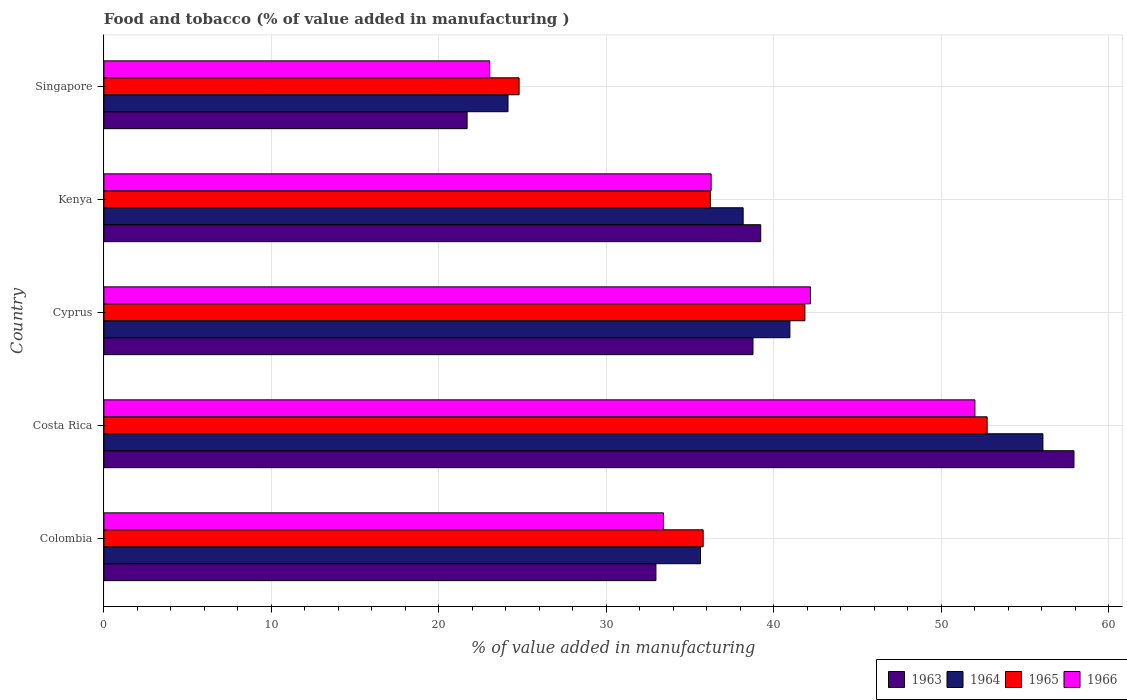How many different coloured bars are there?
Your answer should be very brief. 4. How many groups of bars are there?
Keep it short and to the point. 5. How many bars are there on the 1st tick from the top?
Give a very brief answer. 4. What is the label of the 3rd group of bars from the top?
Your answer should be compact. Cyprus. What is the value added in manufacturing food and tobacco in 1964 in Cyprus?
Give a very brief answer. 40.96. Across all countries, what is the maximum value added in manufacturing food and tobacco in 1965?
Provide a short and direct response. 52.73. Across all countries, what is the minimum value added in manufacturing food and tobacco in 1966?
Your response must be concise. 23.04. In which country was the value added in manufacturing food and tobacco in 1964 maximum?
Give a very brief answer. Costa Rica. In which country was the value added in manufacturing food and tobacco in 1964 minimum?
Your response must be concise. Singapore. What is the total value added in manufacturing food and tobacco in 1964 in the graph?
Give a very brief answer. 194.94. What is the difference between the value added in manufacturing food and tobacco in 1963 in Cyprus and that in Kenya?
Make the answer very short. -0.46. What is the difference between the value added in manufacturing food and tobacco in 1966 in Colombia and the value added in manufacturing food and tobacco in 1963 in Singapore?
Provide a succinct answer. 11.72. What is the average value added in manufacturing food and tobacco in 1966 per country?
Your answer should be compact. 37.38. What is the difference between the value added in manufacturing food and tobacco in 1966 and value added in manufacturing food and tobacco in 1964 in Colombia?
Offer a very short reply. -2.21. In how many countries, is the value added in manufacturing food and tobacco in 1964 greater than 46 %?
Your response must be concise. 1. What is the ratio of the value added in manufacturing food and tobacco in 1965 in Costa Rica to that in Cyprus?
Your response must be concise. 1.26. Is the value added in manufacturing food and tobacco in 1963 in Colombia less than that in Costa Rica?
Keep it short and to the point. Yes. Is the difference between the value added in manufacturing food and tobacco in 1966 in Costa Rica and Kenya greater than the difference between the value added in manufacturing food and tobacco in 1964 in Costa Rica and Kenya?
Offer a very short reply. No. What is the difference between the highest and the second highest value added in manufacturing food and tobacco in 1964?
Offer a terse response. 15.11. What is the difference between the highest and the lowest value added in manufacturing food and tobacco in 1965?
Your answer should be compact. 27.94. In how many countries, is the value added in manufacturing food and tobacco in 1963 greater than the average value added in manufacturing food and tobacco in 1963 taken over all countries?
Provide a succinct answer. 3. What does the 2nd bar from the bottom in Kenya represents?
Keep it short and to the point. 1964. Is it the case that in every country, the sum of the value added in manufacturing food and tobacco in 1965 and value added in manufacturing food and tobacco in 1963 is greater than the value added in manufacturing food and tobacco in 1964?
Offer a terse response. Yes. How many bars are there?
Make the answer very short. 20. How many countries are there in the graph?
Your response must be concise. 5. What is the difference between two consecutive major ticks on the X-axis?
Your answer should be compact. 10. Are the values on the major ticks of X-axis written in scientific E-notation?
Your answer should be compact. No. Does the graph contain any zero values?
Offer a terse response. No. Does the graph contain grids?
Keep it short and to the point. Yes. What is the title of the graph?
Keep it short and to the point. Food and tobacco (% of value added in manufacturing ). Does "2011" appear as one of the legend labels in the graph?
Your answer should be very brief. No. What is the label or title of the X-axis?
Your response must be concise. % of value added in manufacturing. What is the label or title of the Y-axis?
Give a very brief answer. Country. What is the % of value added in manufacturing in 1963 in Colombia?
Make the answer very short. 32.96. What is the % of value added in manufacturing in 1964 in Colombia?
Give a very brief answer. 35.62. What is the % of value added in manufacturing of 1965 in Colombia?
Ensure brevity in your answer.  35.78. What is the % of value added in manufacturing in 1966 in Colombia?
Offer a terse response. 33.41. What is the % of value added in manufacturing of 1963 in Costa Rica?
Ensure brevity in your answer.  57.92. What is the % of value added in manufacturing in 1964 in Costa Rica?
Your response must be concise. 56.07. What is the % of value added in manufacturing in 1965 in Costa Rica?
Make the answer very short. 52.73. What is the % of value added in manufacturing in 1966 in Costa Rica?
Offer a terse response. 52. What is the % of value added in manufacturing of 1963 in Cyprus?
Ensure brevity in your answer.  38.75. What is the % of value added in manufacturing in 1964 in Cyprus?
Offer a terse response. 40.96. What is the % of value added in manufacturing of 1965 in Cyprus?
Keep it short and to the point. 41.85. What is the % of value added in manufacturing in 1966 in Cyprus?
Offer a terse response. 42.19. What is the % of value added in manufacturing of 1963 in Kenya?
Provide a succinct answer. 39.22. What is the % of value added in manufacturing in 1964 in Kenya?
Your answer should be very brief. 38.17. What is the % of value added in manufacturing of 1965 in Kenya?
Provide a succinct answer. 36.2. What is the % of value added in manufacturing in 1966 in Kenya?
Your answer should be compact. 36.25. What is the % of value added in manufacturing of 1963 in Singapore?
Offer a terse response. 21.69. What is the % of value added in manufacturing of 1964 in Singapore?
Offer a very short reply. 24.13. What is the % of value added in manufacturing in 1965 in Singapore?
Your answer should be very brief. 24.79. What is the % of value added in manufacturing of 1966 in Singapore?
Provide a short and direct response. 23.04. Across all countries, what is the maximum % of value added in manufacturing of 1963?
Keep it short and to the point. 57.92. Across all countries, what is the maximum % of value added in manufacturing of 1964?
Give a very brief answer. 56.07. Across all countries, what is the maximum % of value added in manufacturing in 1965?
Offer a very short reply. 52.73. Across all countries, what is the maximum % of value added in manufacturing in 1966?
Ensure brevity in your answer.  52. Across all countries, what is the minimum % of value added in manufacturing in 1963?
Offer a very short reply. 21.69. Across all countries, what is the minimum % of value added in manufacturing in 1964?
Keep it short and to the point. 24.13. Across all countries, what is the minimum % of value added in manufacturing of 1965?
Offer a terse response. 24.79. Across all countries, what is the minimum % of value added in manufacturing in 1966?
Your answer should be compact. 23.04. What is the total % of value added in manufacturing of 1963 in the graph?
Offer a terse response. 190.54. What is the total % of value added in manufacturing of 1964 in the graph?
Give a very brief answer. 194.94. What is the total % of value added in manufacturing in 1965 in the graph?
Your answer should be very brief. 191.36. What is the total % of value added in manufacturing in 1966 in the graph?
Ensure brevity in your answer.  186.89. What is the difference between the % of value added in manufacturing in 1963 in Colombia and that in Costa Rica?
Your answer should be very brief. -24.96. What is the difference between the % of value added in manufacturing of 1964 in Colombia and that in Costa Rica?
Ensure brevity in your answer.  -20.45. What is the difference between the % of value added in manufacturing of 1965 in Colombia and that in Costa Rica?
Your answer should be compact. -16.95. What is the difference between the % of value added in manufacturing in 1966 in Colombia and that in Costa Rica?
Your response must be concise. -18.59. What is the difference between the % of value added in manufacturing in 1963 in Colombia and that in Cyprus?
Offer a terse response. -5.79. What is the difference between the % of value added in manufacturing in 1964 in Colombia and that in Cyprus?
Give a very brief answer. -5.34. What is the difference between the % of value added in manufacturing in 1965 in Colombia and that in Cyprus?
Ensure brevity in your answer.  -6.07. What is the difference between the % of value added in manufacturing of 1966 in Colombia and that in Cyprus?
Offer a terse response. -8.78. What is the difference between the % of value added in manufacturing of 1963 in Colombia and that in Kenya?
Give a very brief answer. -6.26. What is the difference between the % of value added in manufacturing in 1964 in Colombia and that in Kenya?
Offer a terse response. -2.55. What is the difference between the % of value added in manufacturing in 1965 in Colombia and that in Kenya?
Your response must be concise. -0.42. What is the difference between the % of value added in manufacturing in 1966 in Colombia and that in Kenya?
Your answer should be very brief. -2.84. What is the difference between the % of value added in manufacturing in 1963 in Colombia and that in Singapore?
Make the answer very short. 11.27. What is the difference between the % of value added in manufacturing of 1964 in Colombia and that in Singapore?
Your response must be concise. 11.49. What is the difference between the % of value added in manufacturing in 1965 in Colombia and that in Singapore?
Your answer should be compact. 10.99. What is the difference between the % of value added in manufacturing of 1966 in Colombia and that in Singapore?
Your answer should be compact. 10.37. What is the difference between the % of value added in manufacturing of 1963 in Costa Rica and that in Cyprus?
Provide a short and direct response. 19.17. What is the difference between the % of value added in manufacturing in 1964 in Costa Rica and that in Cyprus?
Offer a very short reply. 15.11. What is the difference between the % of value added in manufacturing of 1965 in Costa Rica and that in Cyprus?
Offer a terse response. 10.88. What is the difference between the % of value added in manufacturing of 1966 in Costa Rica and that in Cyprus?
Give a very brief answer. 9.82. What is the difference between the % of value added in manufacturing in 1963 in Costa Rica and that in Kenya?
Give a very brief answer. 18.7. What is the difference between the % of value added in manufacturing in 1964 in Costa Rica and that in Kenya?
Give a very brief answer. 17.9. What is the difference between the % of value added in manufacturing of 1965 in Costa Rica and that in Kenya?
Offer a very short reply. 16.53. What is the difference between the % of value added in manufacturing in 1966 in Costa Rica and that in Kenya?
Your answer should be very brief. 15.75. What is the difference between the % of value added in manufacturing of 1963 in Costa Rica and that in Singapore?
Your answer should be compact. 36.23. What is the difference between the % of value added in manufacturing of 1964 in Costa Rica and that in Singapore?
Ensure brevity in your answer.  31.94. What is the difference between the % of value added in manufacturing in 1965 in Costa Rica and that in Singapore?
Provide a succinct answer. 27.94. What is the difference between the % of value added in manufacturing in 1966 in Costa Rica and that in Singapore?
Your answer should be compact. 28.97. What is the difference between the % of value added in manufacturing of 1963 in Cyprus and that in Kenya?
Make the answer very short. -0.46. What is the difference between the % of value added in manufacturing in 1964 in Cyprus and that in Kenya?
Your answer should be compact. 2.79. What is the difference between the % of value added in manufacturing of 1965 in Cyprus and that in Kenya?
Keep it short and to the point. 5.65. What is the difference between the % of value added in manufacturing of 1966 in Cyprus and that in Kenya?
Your answer should be very brief. 5.93. What is the difference between the % of value added in manufacturing of 1963 in Cyprus and that in Singapore?
Make the answer very short. 17.07. What is the difference between the % of value added in manufacturing in 1964 in Cyprus and that in Singapore?
Your answer should be very brief. 16.83. What is the difference between the % of value added in manufacturing of 1965 in Cyprus and that in Singapore?
Offer a very short reply. 17.06. What is the difference between the % of value added in manufacturing of 1966 in Cyprus and that in Singapore?
Provide a short and direct response. 19.15. What is the difference between the % of value added in manufacturing in 1963 in Kenya and that in Singapore?
Offer a very short reply. 17.53. What is the difference between the % of value added in manufacturing of 1964 in Kenya and that in Singapore?
Give a very brief answer. 14.04. What is the difference between the % of value added in manufacturing of 1965 in Kenya and that in Singapore?
Make the answer very short. 11.41. What is the difference between the % of value added in manufacturing of 1966 in Kenya and that in Singapore?
Offer a very short reply. 13.22. What is the difference between the % of value added in manufacturing in 1963 in Colombia and the % of value added in manufacturing in 1964 in Costa Rica?
Ensure brevity in your answer.  -23.11. What is the difference between the % of value added in manufacturing of 1963 in Colombia and the % of value added in manufacturing of 1965 in Costa Rica?
Ensure brevity in your answer.  -19.77. What is the difference between the % of value added in manufacturing of 1963 in Colombia and the % of value added in manufacturing of 1966 in Costa Rica?
Your answer should be very brief. -19.04. What is the difference between the % of value added in manufacturing in 1964 in Colombia and the % of value added in manufacturing in 1965 in Costa Rica?
Your response must be concise. -17.11. What is the difference between the % of value added in manufacturing of 1964 in Colombia and the % of value added in manufacturing of 1966 in Costa Rica?
Give a very brief answer. -16.38. What is the difference between the % of value added in manufacturing of 1965 in Colombia and the % of value added in manufacturing of 1966 in Costa Rica?
Your response must be concise. -16.22. What is the difference between the % of value added in manufacturing in 1963 in Colombia and the % of value added in manufacturing in 1964 in Cyprus?
Keep it short and to the point. -8. What is the difference between the % of value added in manufacturing of 1963 in Colombia and the % of value added in manufacturing of 1965 in Cyprus?
Offer a terse response. -8.89. What is the difference between the % of value added in manufacturing of 1963 in Colombia and the % of value added in manufacturing of 1966 in Cyprus?
Make the answer very short. -9.23. What is the difference between the % of value added in manufacturing in 1964 in Colombia and the % of value added in manufacturing in 1965 in Cyprus?
Make the answer very short. -6.23. What is the difference between the % of value added in manufacturing of 1964 in Colombia and the % of value added in manufacturing of 1966 in Cyprus?
Your answer should be compact. -6.57. What is the difference between the % of value added in manufacturing in 1965 in Colombia and the % of value added in manufacturing in 1966 in Cyprus?
Give a very brief answer. -6.41. What is the difference between the % of value added in manufacturing of 1963 in Colombia and the % of value added in manufacturing of 1964 in Kenya?
Give a very brief answer. -5.21. What is the difference between the % of value added in manufacturing in 1963 in Colombia and the % of value added in manufacturing in 1965 in Kenya?
Offer a terse response. -3.24. What is the difference between the % of value added in manufacturing in 1963 in Colombia and the % of value added in manufacturing in 1966 in Kenya?
Your answer should be very brief. -3.29. What is the difference between the % of value added in manufacturing in 1964 in Colombia and the % of value added in manufacturing in 1965 in Kenya?
Your answer should be compact. -0.58. What is the difference between the % of value added in manufacturing in 1964 in Colombia and the % of value added in manufacturing in 1966 in Kenya?
Provide a succinct answer. -0.63. What is the difference between the % of value added in manufacturing in 1965 in Colombia and the % of value added in manufacturing in 1966 in Kenya?
Ensure brevity in your answer.  -0.47. What is the difference between the % of value added in manufacturing of 1963 in Colombia and the % of value added in manufacturing of 1964 in Singapore?
Make the answer very short. 8.83. What is the difference between the % of value added in manufacturing of 1963 in Colombia and the % of value added in manufacturing of 1965 in Singapore?
Keep it short and to the point. 8.17. What is the difference between the % of value added in manufacturing in 1963 in Colombia and the % of value added in manufacturing in 1966 in Singapore?
Make the answer very short. 9.92. What is the difference between the % of value added in manufacturing of 1964 in Colombia and the % of value added in manufacturing of 1965 in Singapore?
Offer a very short reply. 10.83. What is the difference between the % of value added in manufacturing in 1964 in Colombia and the % of value added in manufacturing in 1966 in Singapore?
Keep it short and to the point. 12.58. What is the difference between the % of value added in manufacturing in 1965 in Colombia and the % of value added in manufacturing in 1966 in Singapore?
Keep it short and to the point. 12.74. What is the difference between the % of value added in manufacturing of 1963 in Costa Rica and the % of value added in manufacturing of 1964 in Cyprus?
Your answer should be compact. 16.96. What is the difference between the % of value added in manufacturing in 1963 in Costa Rica and the % of value added in manufacturing in 1965 in Cyprus?
Your response must be concise. 16.07. What is the difference between the % of value added in manufacturing of 1963 in Costa Rica and the % of value added in manufacturing of 1966 in Cyprus?
Offer a terse response. 15.73. What is the difference between the % of value added in manufacturing of 1964 in Costa Rica and the % of value added in manufacturing of 1965 in Cyprus?
Offer a very short reply. 14.21. What is the difference between the % of value added in manufacturing in 1964 in Costa Rica and the % of value added in manufacturing in 1966 in Cyprus?
Your answer should be compact. 13.88. What is the difference between the % of value added in manufacturing in 1965 in Costa Rica and the % of value added in manufacturing in 1966 in Cyprus?
Your response must be concise. 10.55. What is the difference between the % of value added in manufacturing in 1963 in Costa Rica and the % of value added in manufacturing in 1964 in Kenya?
Offer a terse response. 19.75. What is the difference between the % of value added in manufacturing of 1963 in Costa Rica and the % of value added in manufacturing of 1965 in Kenya?
Provide a short and direct response. 21.72. What is the difference between the % of value added in manufacturing in 1963 in Costa Rica and the % of value added in manufacturing in 1966 in Kenya?
Give a very brief answer. 21.67. What is the difference between the % of value added in manufacturing in 1964 in Costa Rica and the % of value added in manufacturing in 1965 in Kenya?
Provide a succinct answer. 19.86. What is the difference between the % of value added in manufacturing in 1964 in Costa Rica and the % of value added in manufacturing in 1966 in Kenya?
Give a very brief answer. 19.81. What is the difference between the % of value added in manufacturing of 1965 in Costa Rica and the % of value added in manufacturing of 1966 in Kenya?
Ensure brevity in your answer.  16.48. What is the difference between the % of value added in manufacturing in 1963 in Costa Rica and the % of value added in manufacturing in 1964 in Singapore?
Ensure brevity in your answer.  33.79. What is the difference between the % of value added in manufacturing of 1963 in Costa Rica and the % of value added in manufacturing of 1965 in Singapore?
Give a very brief answer. 33.13. What is the difference between the % of value added in manufacturing in 1963 in Costa Rica and the % of value added in manufacturing in 1966 in Singapore?
Give a very brief answer. 34.88. What is the difference between the % of value added in manufacturing of 1964 in Costa Rica and the % of value added in manufacturing of 1965 in Singapore?
Keep it short and to the point. 31.28. What is the difference between the % of value added in manufacturing of 1964 in Costa Rica and the % of value added in manufacturing of 1966 in Singapore?
Offer a very short reply. 33.03. What is the difference between the % of value added in manufacturing in 1965 in Costa Rica and the % of value added in manufacturing in 1966 in Singapore?
Give a very brief answer. 29.7. What is the difference between the % of value added in manufacturing in 1963 in Cyprus and the % of value added in manufacturing in 1964 in Kenya?
Your answer should be compact. 0.59. What is the difference between the % of value added in manufacturing in 1963 in Cyprus and the % of value added in manufacturing in 1965 in Kenya?
Keep it short and to the point. 2.55. What is the difference between the % of value added in manufacturing in 1963 in Cyprus and the % of value added in manufacturing in 1966 in Kenya?
Your response must be concise. 2.5. What is the difference between the % of value added in manufacturing of 1964 in Cyprus and the % of value added in manufacturing of 1965 in Kenya?
Give a very brief answer. 4.75. What is the difference between the % of value added in manufacturing in 1964 in Cyprus and the % of value added in manufacturing in 1966 in Kenya?
Your response must be concise. 4.7. What is the difference between the % of value added in manufacturing of 1965 in Cyprus and the % of value added in manufacturing of 1966 in Kenya?
Your answer should be compact. 5.6. What is the difference between the % of value added in manufacturing of 1963 in Cyprus and the % of value added in manufacturing of 1964 in Singapore?
Provide a succinct answer. 14.63. What is the difference between the % of value added in manufacturing of 1963 in Cyprus and the % of value added in manufacturing of 1965 in Singapore?
Make the answer very short. 13.96. What is the difference between the % of value added in manufacturing of 1963 in Cyprus and the % of value added in manufacturing of 1966 in Singapore?
Your response must be concise. 15.72. What is the difference between the % of value added in manufacturing in 1964 in Cyprus and the % of value added in manufacturing in 1965 in Singapore?
Your answer should be very brief. 16.17. What is the difference between the % of value added in manufacturing of 1964 in Cyprus and the % of value added in manufacturing of 1966 in Singapore?
Your response must be concise. 17.92. What is the difference between the % of value added in manufacturing of 1965 in Cyprus and the % of value added in manufacturing of 1966 in Singapore?
Provide a succinct answer. 18.82. What is the difference between the % of value added in manufacturing in 1963 in Kenya and the % of value added in manufacturing in 1964 in Singapore?
Your answer should be compact. 15.09. What is the difference between the % of value added in manufacturing in 1963 in Kenya and the % of value added in manufacturing in 1965 in Singapore?
Keep it short and to the point. 14.43. What is the difference between the % of value added in manufacturing in 1963 in Kenya and the % of value added in manufacturing in 1966 in Singapore?
Keep it short and to the point. 16.18. What is the difference between the % of value added in manufacturing of 1964 in Kenya and the % of value added in manufacturing of 1965 in Singapore?
Make the answer very short. 13.38. What is the difference between the % of value added in manufacturing of 1964 in Kenya and the % of value added in manufacturing of 1966 in Singapore?
Your answer should be compact. 15.13. What is the difference between the % of value added in manufacturing of 1965 in Kenya and the % of value added in manufacturing of 1966 in Singapore?
Keep it short and to the point. 13.17. What is the average % of value added in manufacturing of 1963 per country?
Provide a succinct answer. 38.11. What is the average % of value added in manufacturing in 1964 per country?
Offer a terse response. 38.99. What is the average % of value added in manufacturing in 1965 per country?
Provide a succinct answer. 38.27. What is the average % of value added in manufacturing in 1966 per country?
Ensure brevity in your answer.  37.38. What is the difference between the % of value added in manufacturing of 1963 and % of value added in manufacturing of 1964 in Colombia?
Make the answer very short. -2.66. What is the difference between the % of value added in manufacturing in 1963 and % of value added in manufacturing in 1965 in Colombia?
Your answer should be very brief. -2.82. What is the difference between the % of value added in manufacturing in 1963 and % of value added in manufacturing in 1966 in Colombia?
Your response must be concise. -0.45. What is the difference between the % of value added in manufacturing in 1964 and % of value added in manufacturing in 1965 in Colombia?
Provide a succinct answer. -0.16. What is the difference between the % of value added in manufacturing in 1964 and % of value added in manufacturing in 1966 in Colombia?
Offer a terse response. 2.21. What is the difference between the % of value added in manufacturing in 1965 and % of value added in manufacturing in 1966 in Colombia?
Your answer should be compact. 2.37. What is the difference between the % of value added in manufacturing in 1963 and % of value added in manufacturing in 1964 in Costa Rica?
Provide a succinct answer. 1.85. What is the difference between the % of value added in manufacturing of 1963 and % of value added in manufacturing of 1965 in Costa Rica?
Offer a terse response. 5.19. What is the difference between the % of value added in manufacturing of 1963 and % of value added in manufacturing of 1966 in Costa Rica?
Ensure brevity in your answer.  5.92. What is the difference between the % of value added in manufacturing of 1964 and % of value added in manufacturing of 1965 in Costa Rica?
Provide a succinct answer. 3.33. What is the difference between the % of value added in manufacturing of 1964 and % of value added in manufacturing of 1966 in Costa Rica?
Your answer should be compact. 4.06. What is the difference between the % of value added in manufacturing of 1965 and % of value added in manufacturing of 1966 in Costa Rica?
Keep it short and to the point. 0.73. What is the difference between the % of value added in manufacturing in 1963 and % of value added in manufacturing in 1964 in Cyprus?
Ensure brevity in your answer.  -2.2. What is the difference between the % of value added in manufacturing of 1963 and % of value added in manufacturing of 1965 in Cyprus?
Offer a terse response. -3.1. What is the difference between the % of value added in manufacturing of 1963 and % of value added in manufacturing of 1966 in Cyprus?
Your response must be concise. -3.43. What is the difference between the % of value added in manufacturing in 1964 and % of value added in manufacturing in 1965 in Cyprus?
Your response must be concise. -0.9. What is the difference between the % of value added in manufacturing of 1964 and % of value added in manufacturing of 1966 in Cyprus?
Offer a very short reply. -1.23. What is the difference between the % of value added in manufacturing of 1963 and % of value added in manufacturing of 1964 in Kenya?
Keep it short and to the point. 1.05. What is the difference between the % of value added in manufacturing in 1963 and % of value added in manufacturing in 1965 in Kenya?
Your response must be concise. 3.01. What is the difference between the % of value added in manufacturing of 1963 and % of value added in manufacturing of 1966 in Kenya?
Provide a short and direct response. 2.96. What is the difference between the % of value added in manufacturing in 1964 and % of value added in manufacturing in 1965 in Kenya?
Provide a succinct answer. 1.96. What is the difference between the % of value added in manufacturing of 1964 and % of value added in manufacturing of 1966 in Kenya?
Make the answer very short. 1.91. What is the difference between the % of value added in manufacturing in 1965 and % of value added in manufacturing in 1966 in Kenya?
Offer a very short reply. -0.05. What is the difference between the % of value added in manufacturing of 1963 and % of value added in manufacturing of 1964 in Singapore?
Keep it short and to the point. -2.44. What is the difference between the % of value added in manufacturing of 1963 and % of value added in manufacturing of 1965 in Singapore?
Keep it short and to the point. -3.1. What is the difference between the % of value added in manufacturing of 1963 and % of value added in manufacturing of 1966 in Singapore?
Your response must be concise. -1.35. What is the difference between the % of value added in manufacturing of 1964 and % of value added in manufacturing of 1965 in Singapore?
Offer a very short reply. -0.66. What is the difference between the % of value added in manufacturing in 1964 and % of value added in manufacturing in 1966 in Singapore?
Keep it short and to the point. 1.09. What is the difference between the % of value added in manufacturing of 1965 and % of value added in manufacturing of 1966 in Singapore?
Your answer should be compact. 1.75. What is the ratio of the % of value added in manufacturing in 1963 in Colombia to that in Costa Rica?
Your answer should be very brief. 0.57. What is the ratio of the % of value added in manufacturing in 1964 in Colombia to that in Costa Rica?
Your answer should be compact. 0.64. What is the ratio of the % of value added in manufacturing in 1965 in Colombia to that in Costa Rica?
Offer a very short reply. 0.68. What is the ratio of the % of value added in manufacturing of 1966 in Colombia to that in Costa Rica?
Keep it short and to the point. 0.64. What is the ratio of the % of value added in manufacturing of 1963 in Colombia to that in Cyprus?
Keep it short and to the point. 0.85. What is the ratio of the % of value added in manufacturing in 1964 in Colombia to that in Cyprus?
Provide a succinct answer. 0.87. What is the ratio of the % of value added in manufacturing in 1965 in Colombia to that in Cyprus?
Your response must be concise. 0.85. What is the ratio of the % of value added in manufacturing of 1966 in Colombia to that in Cyprus?
Provide a short and direct response. 0.79. What is the ratio of the % of value added in manufacturing of 1963 in Colombia to that in Kenya?
Keep it short and to the point. 0.84. What is the ratio of the % of value added in manufacturing of 1964 in Colombia to that in Kenya?
Keep it short and to the point. 0.93. What is the ratio of the % of value added in manufacturing of 1965 in Colombia to that in Kenya?
Your answer should be very brief. 0.99. What is the ratio of the % of value added in manufacturing of 1966 in Colombia to that in Kenya?
Provide a succinct answer. 0.92. What is the ratio of the % of value added in manufacturing in 1963 in Colombia to that in Singapore?
Provide a short and direct response. 1.52. What is the ratio of the % of value added in manufacturing in 1964 in Colombia to that in Singapore?
Your answer should be very brief. 1.48. What is the ratio of the % of value added in manufacturing of 1965 in Colombia to that in Singapore?
Make the answer very short. 1.44. What is the ratio of the % of value added in manufacturing of 1966 in Colombia to that in Singapore?
Provide a short and direct response. 1.45. What is the ratio of the % of value added in manufacturing in 1963 in Costa Rica to that in Cyprus?
Offer a terse response. 1.49. What is the ratio of the % of value added in manufacturing in 1964 in Costa Rica to that in Cyprus?
Ensure brevity in your answer.  1.37. What is the ratio of the % of value added in manufacturing of 1965 in Costa Rica to that in Cyprus?
Your answer should be very brief. 1.26. What is the ratio of the % of value added in manufacturing in 1966 in Costa Rica to that in Cyprus?
Ensure brevity in your answer.  1.23. What is the ratio of the % of value added in manufacturing of 1963 in Costa Rica to that in Kenya?
Make the answer very short. 1.48. What is the ratio of the % of value added in manufacturing of 1964 in Costa Rica to that in Kenya?
Give a very brief answer. 1.47. What is the ratio of the % of value added in manufacturing in 1965 in Costa Rica to that in Kenya?
Your answer should be compact. 1.46. What is the ratio of the % of value added in manufacturing of 1966 in Costa Rica to that in Kenya?
Keep it short and to the point. 1.43. What is the ratio of the % of value added in manufacturing of 1963 in Costa Rica to that in Singapore?
Your answer should be compact. 2.67. What is the ratio of the % of value added in manufacturing of 1964 in Costa Rica to that in Singapore?
Offer a terse response. 2.32. What is the ratio of the % of value added in manufacturing of 1965 in Costa Rica to that in Singapore?
Your answer should be compact. 2.13. What is the ratio of the % of value added in manufacturing in 1966 in Costa Rica to that in Singapore?
Keep it short and to the point. 2.26. What is the ratio of the % of value added in manufacturing of 1964 in Cyprus to that in Kenya?
Offer a terse response. 1.07. What is the ratio of the % of value added in manufacturing in 1965 in Cyprus to that in Kenya?
Ensure brevity in your answer.  1.16. What is the ratio of the % of value added in manufacturing of 1966 in Cyprus to that in Kenya?
Provide a succinct answer. 1.16. What is the ratio of the % of value added in manufacturing of 1963 in Cyprus to that in Singapore?
Offer a terse response. 1.79. What is the ratio of the % of value added in manufacturing of 1964 in Cyprus to that in Singapore?
Provide a succinct answer. 1.7. What is the ratio of the % of value added in manufacturing in 1965 in Cyprus to that in Singapore?
Your answer should be very brief. 1.69. What is the ratio of the % of value added in manufacturing in 1966 in Cyprus to that in Singapore?
Give a very brief answer. 1.83. What is the ratio of the % of value added in manufacturing in 1963 in Kenya to that in Singapore?
Offer a very short reply. 1.81. What is the ratio of the % of value added in manufacturing in 1964 in Kenya to that in Singapore?
Offer a very short reply. 1.58. What is the ratio of the % of value added in manufacturing of 1965 in Kenya to that in Singapore?
Offer a very short reply. 1.46. What is the ratio of the % of value added in manufacturing of 1966 in Kenya to that in Singapore?
Your answer should be very brief. 1.57. What is the difference between the highest and the second highest % of value added in manufacturing of 1963?
Ensure brevity in your answer.  18.7. What is the difference between the highest and the second highest % of value added in manufacturing of 1964?
Your answer should be very brief. 15.11. What is the difference between the highest and the second highest % of value added in manufacturing of 1965?
Keep it short and to the point. 10.88. What is the difference between the highest and the second highest % of value added in manufacturing in 1966?
Offer a very short reply. 9.82. What is the difference between the highest and the lowest % of value added in manufacturing in 1963?
Give a very brief answer. 36.23. What is the difference between the highest and the lowest % of value added in manufacturing of 1964?
Keep it short and to the point. 31.94. What is the difference between the highest and the lowest % of value added in manufacturing in 1965?
Provide a short and direct response. 27.94. What is the difference between the highest and the lowest % of value added in manufacturing in 1966?
Give a very brief answer. 28.97. 